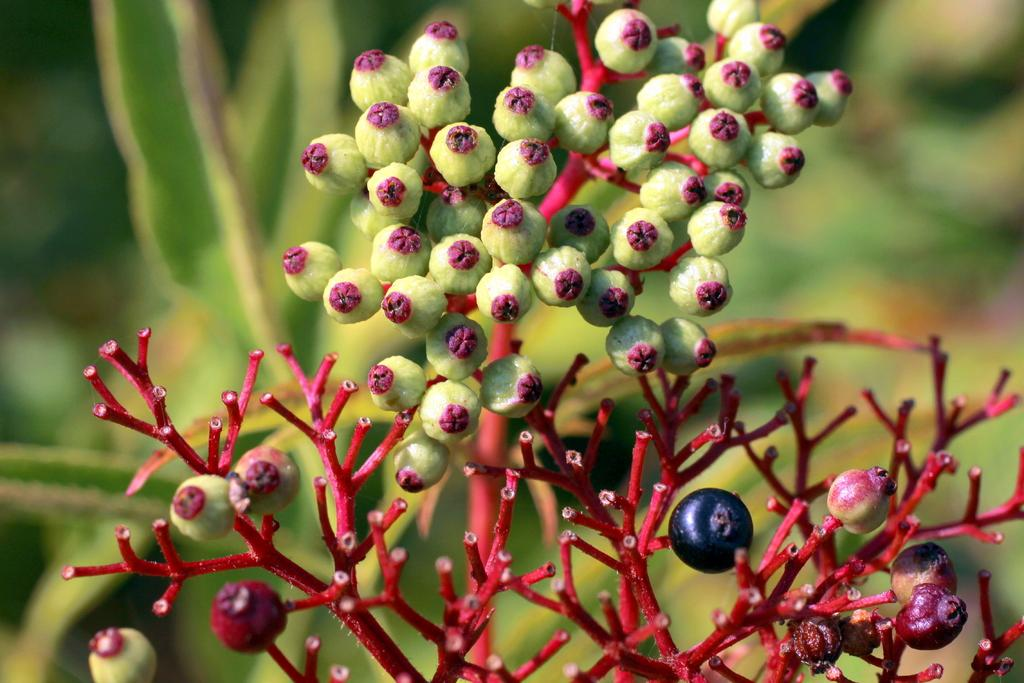What type of living organisms can be seen on the plant in the image? There are fruits on the plant in the image. Can you describe the fruits on the plant? Unfortunately, the specific type of fruits cannot be determined from the image alone. What is the natural setting of the image? The image features a plant with fruits, suggesting a natural setting. What type of snake can be seen slithering across the caption in the image? There is no snake or caption present in the image; it only features a plant with fruits. 